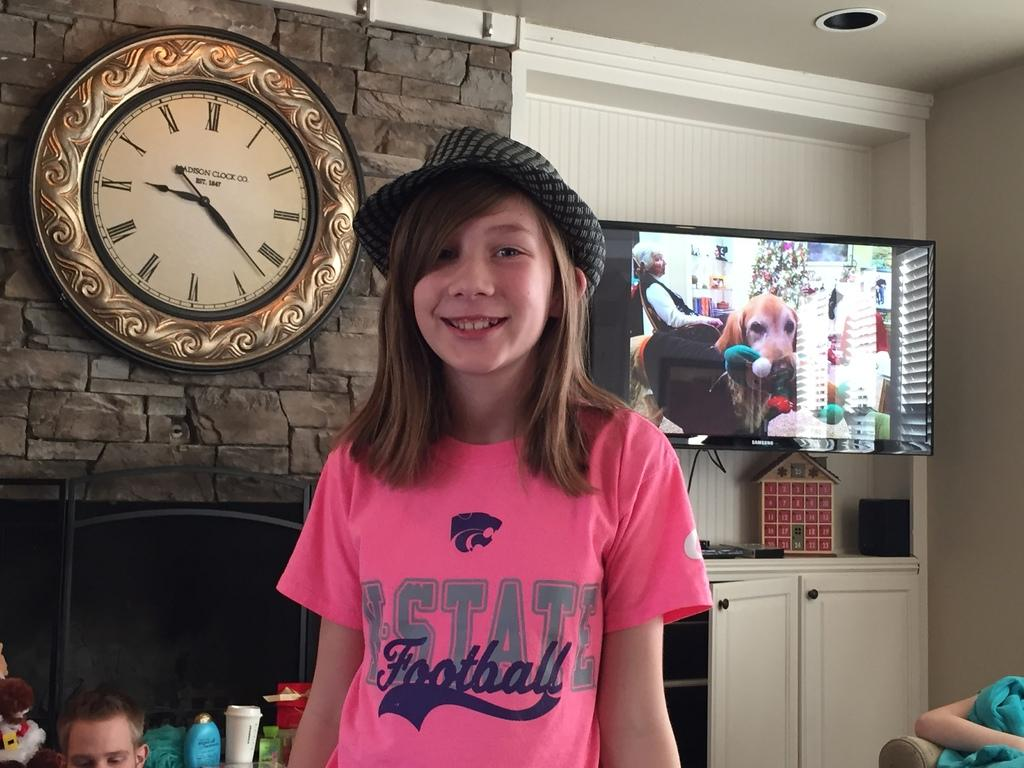Provide a one-sentence caption for the provided image. Girl wearing a hat and a pink shirt that says "State Football". 